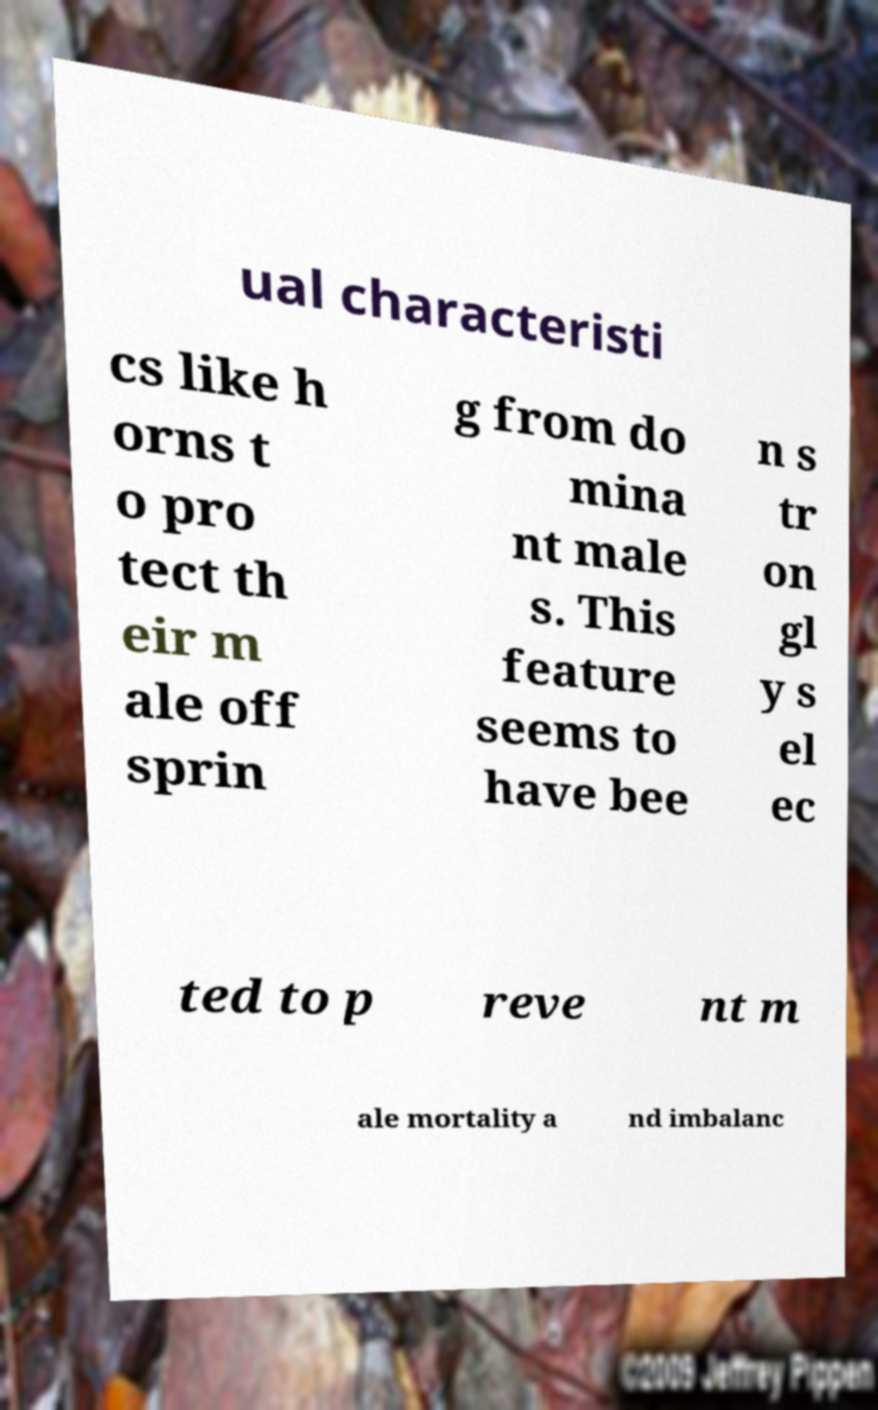Could you extract and type out the text from this image? ual characteristi cs like h orns t o pro tect th eir m ale off sprin g from do mina nt male s. This feature seems to have bee n s tr on gl y s el ec ted to p reve nt m ale mortality a nd imbalanc 